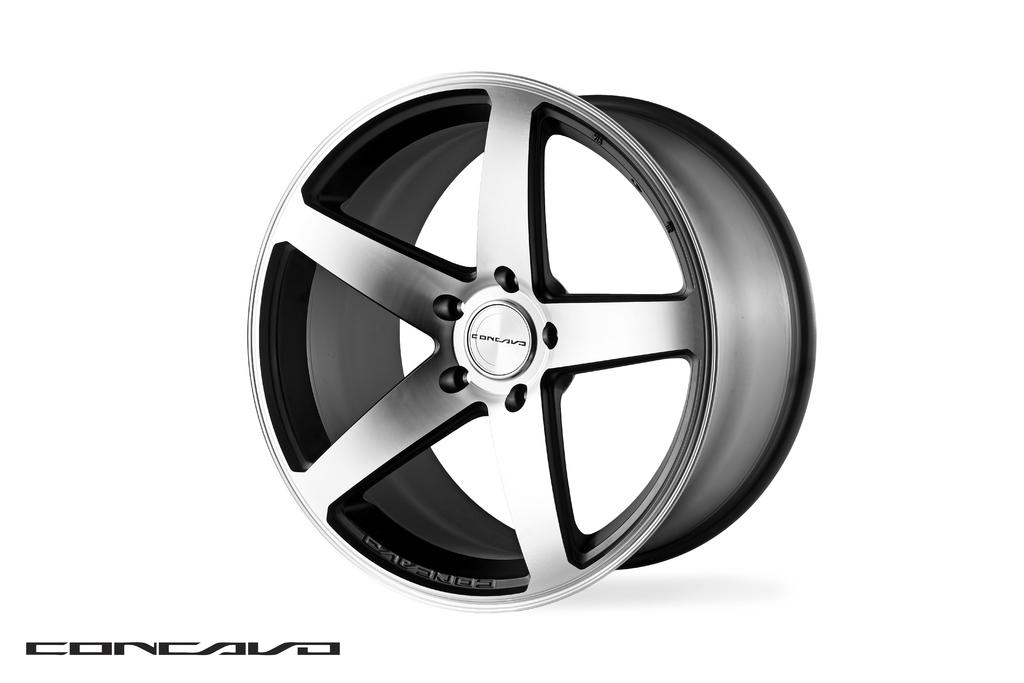What type of image is being described? The image is an animated picture. What is the main subject of the animated picture? The animated picture depicts an alloy wheel. What time of day is depicted in the animated picture? The animated picture does not depict a specific time of day, as it is an animated image of an alloy wheel. 